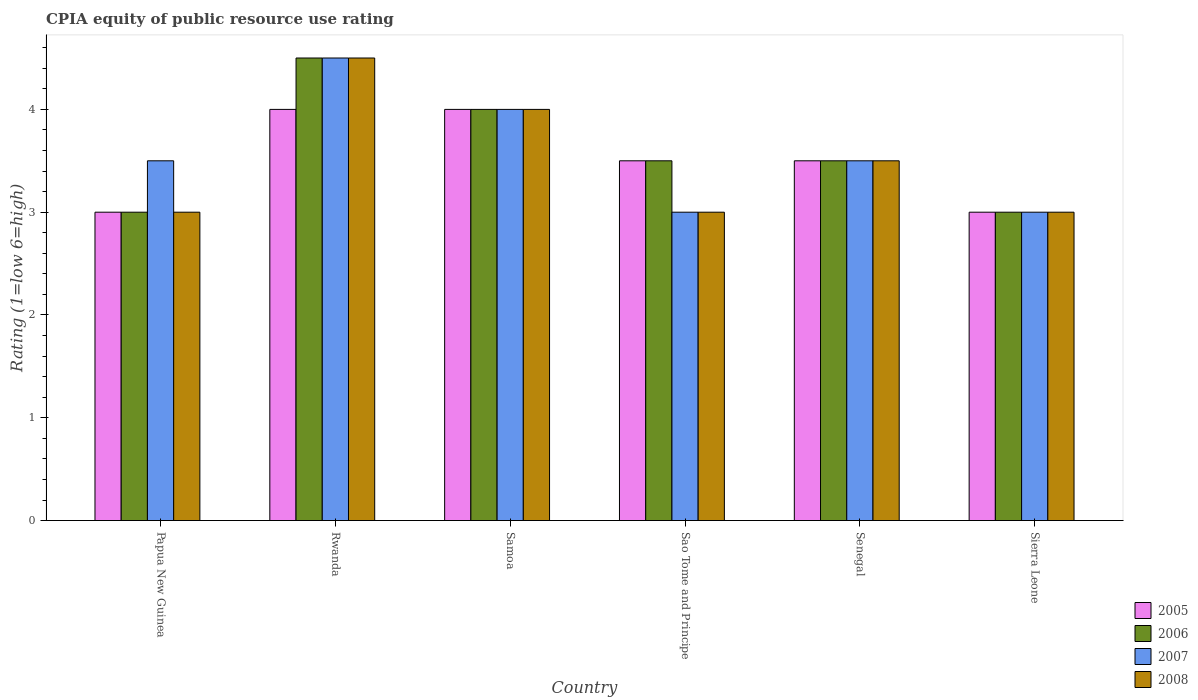How many groups of bars are there?
Ensure brevity in your answer.  6. Are the number of bars per tick equal to the number of legend labels?
Ensure brevity in your answer.  Yes. Are the number of bars on each tick of the X-axis equal?
Ensure brevity in your answer.  Yes. What is the label of the 3rd group of bars from the left?
Your answer should be compact. Samoa. Across all countries, what is the maximum CPIA rating in 2005?
Your answer should be compact. 4. Across all countries, what is the minimum CPIA rating in 2005?
Give a very brief answer. 3. In which country was the CPIA rating in 2007 maximum?
Your answer should be compact. Rwanda. In which country was the CPIA rating in 2008 minimum?
Make the answer very short. Papua New Guinea. What is the difference between the CPIA rating in 2005 in Samoa and that in Sao Tome and Principe?
Provide a short and direct response. 0.5. What is the average CPIA rating in 2008 per country?
Make the answer very short. 3.5. What is the difference between the CPIA rating of/in 2007 and CPIA rating of/in 2005 in Rwanda?
Make the answer very short. 0.5. What is the difference between the highest and the second highest CPIA rating in 2008?
Give a very brief answer. -1. What is the difference between the highest and the lowest CPIA rating in 2005?
Keep it short and to the point. 1. In how many countries, is the CPIA rating in 2007 greater than the average CPIA rating in 2007 taken over all countries?
Your answer should be very brief. 2. Is the sum of the CPIA rating in 2008 in Rwanda and Sao Tome and Principe greater than the maximum CPIA rating in 2006 across all countries?
Make the answer very short. Yes. What does the 2nd bar from the right in Senegal represents?
Your answer should be very brief. 2007. Is it the case that in every country, the sum of the CPIA rating in 2005 and CPIA rating in 2008 is greater than the CPIA rating in 2006?
Provide a short and direct response. Yes. How many countries are there in the graph?
Your answer should be compact. 6. Are the values on the major ticks of Y-axis written in scientific E-notation?
Make the answer very short. No. Does the graph contain any zero values?
Provide a short and direct response. No. Where does the legend appear in the graph?
Make the answer very short. Bottom right. How many legend labels are there?
Provide a short and direct response. 4. What is the title of the graph?
Offer a terse response. CPIA equity of public resource use rating. Does "1960" appear as one of the legend labels in the graph?
Make the answer very short. No. What is the label or title of the Y-axis?
Keep it short and to the point. Rating (1=low 6=high). What is the Rating (1=low 6=high) in 2005 in Papua New Guinea?
Your response must be concise. 3. What is the Rating (1=low 6=high) in 2006 in Papua New Guinea?
Ensure brevity in your answer.  3. What is the Rating (1=low 6=high) of 2008 in Papua New Guinea?
Offer a terse response. 3. What is the Rating (1=low 6=high) of 2005 in Rwanda?
Provide a succinct answer. 4. What is the Rating (1=low 6=high) in 2006 in Rwanda?
Provide a succinct answer. 4.5. What is the Rating (1=low 6=high) in 2005 in Samoa?
Your answer should be compact. 4. What is the Rating (1=low 6=high) in 2008 in Samoa?
Your answer should be very brief. 4. What is the Rating (1=low 6=high) of 2005 in Sao Tome and Principe?
Make the answer very short. 3.5. What is the Rating (1=low 6=high) in 2006 in Sao Tome and Principe?
Your response must be concise. 3.5. What is the Rating (1=low 6=high) of 2007 in Sao Tome and Principe?
Provide a short and direct response. 3. What is the Rating (1=low 6=high) of 2008 in Sao Tome and Principe?
Your answer should be compact. 3. What is the Rating (1=low 6=high) of 2006 in Senegal?
Offer a terse response. 3.5. What is the Rating (1=low 6=high) of 2007 in Sierra Leone?
Provide a short and direct response. 3. What is the Rating (1=low 6=high) in 2008 in Sierra Leone?
Provide a short and direct response. 3. Across all countries, what is the maximum Rating (1=low 6=high) of 2007?
Provide a succinct answer. 4.5. Across all countries, what is the minimum Rating (1=low 6=high) in 2006?
Ensure brevity in your answer.  3. Across all countries, what is the minimum Rating (1=low 6=high) of 2007?
Provide a succinct answer. 3. What is the total Rating (1=low 6=high) of 2005 in the graph?
Make the answer very short. 21. What is the total Rating (1=low 6=high) of 2008 in the graph?
Provide a short and direct response. 21. What is the difference between the Rating (1=low 6=high) of 2008 in Papua New Guinea and that in Rwanda?
Provide a succinct answer. -1.5. What is the difference between the Rating (1=low 6=high) of 2006 in Papua New Guinea and that in Samoa?
Offer a very short reply. -1. What is the difference between the Rating (1=low 6=high) in 2006 in Papua New Guinea and that in Sao Tome and Principe?
Your answer should be compact. -0.5. What is the difference between the Rating (1=low 6=high) of 2007 in Papua New Guinea and that in Sao Tome and Principe?
Your answer should be compact. 0.5. What is the difference between the Rating (1=low 6=high) in 2005 in Papua New Guinea and that in Sierra Leone?
Your answer should be very brief. 0. What is the difference between the Rating (1=low 6=high) in 2007 in Papua New Guinea and that in Sierra Leone?
Give a very brief answer. 0.5. What is the difference between the Rating (1=low 6=high) in 2008 in Papua New Guinea and that in Sierra Leone?
Keep it short and to the point. 0. What is the difference between the Rating (1=low 6=high) of 2005 in Rwanda and that in Samoa?
Keep it short and to the point. 0. What is the difference between the Rating (1=low 6=high) in 2006 in Rwanda and that in Samoa?
Offer a terse response. 0.5. What is the difference between the Rating (1=low 6=high) of 2007 in Rwanda and that in Samoa?
Make the answer very short. 0.5. What is the difference between the Rating (1=low 6=high) in 2008 in Rwanda and that in Samoa?
Offer a very short reply. 0.5. What is the difference between the Rating (1=low 6=high) in 2005 in Rwanda and that in Sao Tome and Principe?
Make the answer very short. 0.5. What is the difference between the Rating (1=low 6=high) in 2007 in Rwanda and that in Sao Tome and Principe?
Give a very brief answer. 1.5. What is the difference between the Rating (1=low 6=high) in 2008 in Rwanda and that in Senegal?
Give a very brief answer. 1. What is the difference between the Rating (1=low 6=high) in 2008 in Rwanda and that in Sierra Leone?
Provide a short and direct response. 1.5. What is the difference between the Rating (1=low 6=high) of 2005 in Samoa and that in Sao Tome and Principe?
Make the answer very short. 0.5. What is the difference between the Rating (1=low 6=high) in 2007 in Samoa and that in Sao Tome and Principe?
Your response must be concise. 1. What is the difference between the Rating (1=low 6=high) of 2005 in Samoa and that in Senegal?
Make the answer very short. 0.5. What is the difference between the Rating (1=low 6=high) of 2005 in Samoa and that in Sierra Leone?
Give a very brief answer. 1. What is the difference between the Rating (1=low 6=high) in 2007 in Samoa and that in Sierra Leone?
Provide a short and direct response. 1. What is the difference between the Rating (1=low 6=high) of 2008 in Samoa and that in Sierra Leone?
Your answer should be very brief. 1. What is the difference between the Rating (1=low 6=high) in 2006 in Sao Tome and Principe and that in Senegal?
Provide a short and direct response. 0. What is the difference between the Rating (1=low 6=high) in 2005 in Sao Tome and Principe and that in Sierra Leone?
Make the answer very short. 0.5. What is the difference between the Rating (1=low 6=high) in 2008 in Sao Tome and Principe and that in Sierra Leone?
Make the answer very short. 0. What is the difference between the Rating (1=low 6=high) of 2005 in Senegal and that in Sierra Leone?
Offer a very short reply. 0.5. What is the difference between the Rating (1=low 6=high) of 2007 in Senegal and that in Sierra Leone?
Your answer should be compact. 0.5. What is the difference between the Rating (1=low 6=high) in 2008 in Senegal and that in Sierra Leone?
Keep it short and to the point. 0.5. What is the difference between the Rating (1=low 6=high) of 2005 in Papua New Guinea and the Rating (1=low 6=high) of 2007 in Rwanda?
Offer a terse response. -1.5. What is the difference between the Rating (1=low 6=high) in 2006 in Papua New Guinea and the Rating (1=low 6=high) in 2007 in Rwanda?
Your response must be concise. -1.5. What is the difference between the Rating (1=low 6=high) of 2005 in Papua New Guinea and the Rating (1=low 6=high) of 2008 in Samoa?
Give a very brief answer. -1. What is the difference between the Rating (1=low 6=high) of 2006 in Papua New Guinea and the Rating (1=low 6=high) of 2007 in Samoa?
Make the answer very short. -1. What is the difference between the Rating (1=low 6=high) of 2007 in Papua New Guinea and the Rating (1=low 6=high) of 2008 in Samoa?
Provide a succinct answer. -0.5. What is the difference between the Rating (1=low 6=high) of 2005 in Papua New Guinea and the Rating (1=low 6=high) of 2008 in Sao Tome and Principe?
Ensure brevity in your answer.  0. What is the difference between the Rating (1=low 6=high) in 2006 in Papua New Guinea and the Rating (1=low 6=high) in 2008 in Sao Tome and Principe?
Offer a very short reply. 0. What is the difference between the Rating (1=low 6=high) of 2007 in Papua New Guinea and the Rating (1=low 6=high) of 2008 in Sao Tome and Principe?
Make the answer very short. 0.5. What is the difference between the Rating (1=low 6=high) of 2005 in Papua New Guinea and the Rating (1=low 6=high) of 2006 in Senegal?
Ensure brevity in your answer.  -0.5. What is the difference between the Rating (1=low 6=high) in 2005 in Papua New Guinea and the Rating (1=low 6=high) in 2007 in Senegal?
Keep it short and to the point. -0.5. What is the difference between the Rating (1=low 6=high) of 2005 in Papua New Guinea and the Rating (1=low 6=high) of 2008 in Senegal?
Provide a succinct answer. -0.5. What is the difference between the Rating (1=low 6=high) in 2006 in Papua New Guinea and the Rating (1=low 6=high) in 2008 in Senegal?
Your answer should be compact. -0.5. What is the difference between the Rating (1=low 6=high) of 2005 in Papua New Guinea and the Rating (1=low 6=high) of 2007 in Sierra Leone?
Offer a terse response. 0. What is the difference between the Rating (1=low 6=high) in 2007 in Papua New Guinea and the Rating (1=low 6=high) in 2008 in Sierra Leone?
Make the answer very short. 0.5. What is the difference between the Rating (1=low 6=high) in 2005 in Rwanda and the Rating (1=low 6=high) in 2007 in Samoa?
Your answer should be very brief. 0. What is the difference between the Rating (1=low 6=high) of 2006 in Rwanda and the Rating (1=low 6=high) of 2007 in Samoa?
Make the answer very short. 0.5. What is the difference between the Rating (1=low 6=high) of 2006 in Rwanda and the Rating (1=low 6=high) of 2008 in Samoa?
Offer a terse response. 0.5. What is the difference between the Rating (1=low 6=high) of 2006 in Rwanda and the Rating (1=low 6=high) of 2008 in Sao Tome and Principe?
Ensure brevity in your answer.  1.5. What is the difference between the Rating (1=low 6=high) of 2007 in Rwanda and the Rating (1=low 6=high) of 2008 in Sao Tome and Principe?
Provide a short and direct response. 1.5. What is the difference between the Rating (1=low 6=high) of 2005 in Rwanda and the Rating (1=low 6=high) of 2006 in Senegal?
Keep it short and to the point. 0.5. What is the difference between the Rating (1=low 6=high) of 2005 in Rwanda and the Rating (1=low 6=high) of 2008 in Senegal?
Offer a very short reply. 0.5. What is the difference between the Rating (1=low 6=high) in 2006 in Rwanda and the Rating (1=low 6=high) in 2007 in Senegal?
Ensure brevity in your answer.  1. What is the difference between the Rating (1=low 6=high) of 2006 in Rwanda and the Rating (1=low 6=high) of 2008 in Senegal?
Offer a terse response. 1. What is the difference between the Rating (1=low 6=high) of 2005 in Rwanda and the Rating (1=low 6=high) of 2007 in Sierra Leone?
Ensure brevity in your answer.  1. What is the difference between the Rating (1=low 6=high) of 2006 in Rwanda and the Rating (1=low 6=high) of 2007 in Sierra Leone?
Keep it short and to the point. 1.5. What is the difference between the Rating (1=low 6=high) of 2007 in Rwanda and the Rating (1=low 6=high) of 2008 in Sierra Leone?
Your response must be concise. 1.5. What is the difference between the Rating (1=low 6=high) of 2005 in Samoa and the Rating (1=low 6=high) of 2007 in Sao Tome and Principe?
Ensure brevity in your answer.  1. What is the difference between the Rating (1=low 6=high) in 2007 in Samoa and the Rating (1=low 6=high) in 2008 in Sao Tome and Principe?
Your answer should be compact. 1. What is the difference between the Rating (1=low 6=high) in 2005 in Samoa and the Rating (1=low 6=high) in 2008 in Senegal?
Your answer should be very brief. 0.5. What is the difference between the Rating (1=low 6=high) in 2006 in Samoa and the Rating (1=low 6=high) in 2007 in Senegal?
Your answer should be compact. 0.5. What is the difference between the Rating (1=low 6=high) in 2006 in Samoa and the Rating (1=low 6=high) in 2008 in Senegal?
Ensure brevity in your answer.  0.5. What is the difference between the Rating (1=low 6=high) of 2007 in Samoa and the Rating (1=low 6=high) of 2008 in Senegal?
Make the answer very short. 0.5. What is the difference between the Rating (1=low 6=high) in 2005 in Samoa and the Rating (1=low 6=high) in 2007 in Sierra Leone?
Offer a terse response. 1. What is the difference between the Rating (1=low 6=high) in 2005 in Samoa and the Rating (1=low 6=high) in 2008 in Sierra Leone?
Provide a succinct answer. 1. What is the difference between the Rating (1=low 6=high) of 2005 in Sao Tome and Principe and the Rating (1=low 6=high) of 2006 in Senegal?
Offer a very short reply. 0. What is the difference between the Rating (1=low 6=high) in 2005 in Sao Tome and Principe and the Rating (1=low 6=high) in 2007 in Senegal?
Ensure brevity in your answer.  0. What is the difference between the Rating (1=low 6=high) of 2006 in Sao Tome and Principe and the Rating (1=low 6=high) of 2007 in Senegal?
Your answer should be very brief. 0. What is the difference between the Rating (1=low 6=high) of 2006 in Sao Tome and Principe and the Rating (1=low 6=high) of 2008 in Senegal?
Provide a short and direct response. 0. What is the difference between the Rating (1=low 6=high) in 2005 in Sao Tome and Principe and the Rating (1=low 6=high) in 2007 in Sierra Leone?
Your answer should be very brief. 0.5. What is the difference between the Rating (1=low 6=high) in 2005 in Sao Tome and Principe and the Rating (1=low 6=high) in 2008 in Sierra Leone?
Offer a very short reply. 0.5. What is the difference between the Rating (1=low 6=high) of 2007 in Sao Tome and Principe and the Rating (1=low 6=high) of 2008 in Sierra Leone?
Your answer should be compact. 0. What is the difference between the Rating (1=low 6=high) in 2005 in Senegal and the Rating (1=low 6=high) in 2007 in Sierra Leone?
Give a very brief answer. 0.5. What is the difference between the Rating (1=low 6=high) in 2006 in Senegal and the Rating (1=low 6=high) in 2008 in Sierra Leone?
Your response must be concise. 0.5. What is the difference between the Rating (1=low 6=high) in 2007 in Senegal and the Rating (1=low 6=high) in 2008 in Sierra Leone?
Your answer should be compact. 0.5. What is the average Rating (1=low 6=high) of 2005 per country?
Your answer should be compact. 3.5. What is the average Rating (1=low 6=high) of 2006 per country?
Keep it short and to the point. 3.58. What is the average Rating (1=low 6=high) of 2007 per country?
Ensure brevity in your answer.  3.58. What is the average Rating (1=low 6=high) of 2008 per country?
Provide a short and direct response. 3.5. What is the difference between the Rating (1=low 6=high) in 2005 and Rating (1=low 6=high) in 2006 in Papua New Guinea?
Give a very brief answer. 0. What is the difference between the Rating (1=low 6=high) of 2007 and Rating (1=low 6=high) of 2008 in Papua New Guinea?
Your answer should be compact. 0.5. What is the difference between the Rating (1=low 6=high) of 2005 and Rating (1=low 6=high) of 2008 in Rwanda?
Give a very brief answer. -0.5. What is the difference between the Rating (1=low 6=high) of 2006 and Rating (1=low 6=high) of 2007 in Rwanda?
Your answer should be compact. 0. What is the difference between the Rating (1=low 6=high) of 2005 and Rating (1=low 6=high) of 2007 in Samoa?
Provide a short and direct response. 0. What is the difference between the Rating (1=low 6=high) of 2006 and Rating (1=low 6=high) of 2007 in Samoa?
Your answer should be compact. 0. What is the difference between the Rating (1=low 6=high) of 2007 and Rating (1=low 6=high) of 2008 in Samoa?
Give a very brief answer. 0. What is the difference between the Rating (1=low 6=high) of 2005 and Rating (1=low 6=high) of 2006 in Sao Tome and Principe?
Make the answer very short. 0. What is the difference between the Rating (1=low 6=high) in 2005 and Rating (1=low 6=high) in 2008 in Sao Tome and Principe?
Offer a terse response. 0.5. What is the difference between the Rating (1=low 6=high) of 2006 and Rating (1=low 6=high) of 2008 in Sao Tome and Principe?
Provide a short and direct response. 0.5. What is the difference between the Rating (1=low 6=high) of 2005 and Rating (1=low 6=high) of 2007 in Senegal?
Give a very brief answer. 0. What is the difference between the Rating (1=low 6=high) in 2005 and Rating (1=low 6=high) in 2008 in Senegal?
Provide a short and direct response. 0. What is the difference between the Rating (1=low 6=high) in 2006 and Rating (1=low 6=high) in 2007 in Senegal?
Offer a terse response. 0. What is the difference between the Rating (1=low 6=high) of 2005 and Rating (1=low 6=high) of 2006 in Sierra Leone?
Offer a very short reply. 0. What is the difference between the Rating (1=low 6=high) of 2005 and Rating (1=low 6=high) of 2007 in Sierra Leone?
Your response must be concise. 0. What is the difference between the Rating (1=low 6=high) of 2006 and Rating (1=low 6=high) of 2007 in Sierra Leone?
Give a very brief answer. 0. What is the ratio of the Rating (1=low 6=high) of 2005 in Papua New Guinea to that in Rwanda?
Provide a succinct answer. 0.75. What is the ratio of the Rating (1=low 6=high) in 2007 in Papua New Guinea to that in Rwanda?
Offer a terse response. 0.78. What is the ratio of the Rating (1=low 6=high) in 2007 in Papua New Guinea to that in Samoa?
Your response must be concise. 0.88. What is the ratio of the Rating (1=low 6=high) in 2008 in Papua New Guinea to that in Samoa?
Ensure brevity in your answer.  0.75. What is the ratio of the Rating (1=low 6=high) in 2005 in Papua New Guinea to that in Sao Tome and Principe?
Give a very brief answer. 0.86. What is the ratio of the Rating (1=low 6=high) in 2007 in Papua New Guinea to that in Sao Tome and Principe?
Give a very brief answer. 1.17. What is the ratio of the Rating (1=low 6=high) in 2008 in Papua New Guinea to that in Sao Tome and Principe?
Keep it short and to the point. 1. What is the ratio of the Rating (1=low 6=high) in 2005 in Papua New Guinea to that in Senegal?
Give a very brief answer. 0.86. What is the ratio of the Rating (1=low 6=high) of 2006 in Papua New Guinea to that in Senegal?
Ensure brevity in your answer.  0.86. What is the ratio of the Rating (1=low 6=high) of 2008 in Papua New Guinea to that in Senegal?
Make the answer very short. 0.86. What is the ratio of the Rating (1=low 6=high) of 2005 in Papua New Guinea to that in Sierra Leone?
Make the answer very short. 1. What is the ratio of the Rating (1=low 6=high) of 2007 in Papua New Guinea to that in Sierra Leone?
Provide a short and direct response. 1.17. What is the ratio of the Rating (1=low 6=high) of 2008 in Papua New Guinea to that in Sierra Leone?
Ensure brevity in your answer.  1. What is the ratio of the Rating (1=low 6=high) in 2007 in Rwanda to that in Samoa?
Your response must be concise. 1.12. What is the ratio of the Rating (1=low 6=high) in 2008 in Rwanda to that in Samoa?
Your response must be concise. 1.12. What is the ratio of the Rating (1=low 6=high) in 2006 in Rwanda to that in Sao Tome and Principe?
Your response must be concise. 1.29. What is the ratio of the Rating (1=low 6=high) in 2007 in Rwanda to that in Sao Tome and Principe?
Your response must be concise. 1.5. What is the ratio of the Rating (1=low 6=high) in 2008 in Rwanda to that in Sao Tome and Principe?
Provide a succinct answer. 1.5. What is the ratio of the Rating (1=low 6=high) in 2008 in Rwanda to that in Senegal?
Your answer should be compact. 1.29. What is the ratio of the Rating (1=low 6=high) in 2006 in Rwanda to that in Sierra Leone?
Give a very brief answer. 1.5. What is the ratio of the Rating (1=low 6=high) of 2007 in Rwanda to that in Sierra Leone?
Provide a succinct answer. 1.5. What is the ratio of the Rating (1=low 6=high) in 2005 in Samoa to that in Sao Tome and Principe?
Provide a short and direct response. 1.14. What is the ratio of the Rating (1=low 6=high) in 2006 in Samoa to that in Senegal?
Make the answer very short. 1.14. What is the ratio of the Rating (1=low 6=high) in 2008 in Samoa to that in Senegal?
Keep it short and to the point. 1.14. What is the ratio of the Rating (1=low 6=high) in 2007 in Samoa to that in Sierra Leone?
Your response must be concise. 1.33. What is the ratio of the Rating (1=low 6=high) of 2005 in Sao Tome and Principe to that in Senegal?
Ensure brevity in your answer.  1. What is the ratio of the Rating (1=low 6=high) of 2006 in Sao Tome and Principe to that in Senegal?
Your answer should be very brief. 1. What is the ratio of the Rating (1=low 6=high) in 2008 in Sao Tome and Principe to that in Senegal?
Make the answer very short. 0.86. What is the ratio of the Rating (1=low 6=high) of 2006 in Sao Tome and Principe to that in Sierra Leone?
Provide a succinct answer. 1.17. What is the ratio of the Rating (1=low 6=high) in 2007 in Sao Tome and Principe to that in Sierra Leone?
Your answer should be compact. 1. What is the ratio of the Rating (1=low 6=high) of 2007 in Senegal to that in Sierra Leone?
Provide a short and direct response. 1.17. What is the ratio of the Rating (1=low 6=high) in 2008 in Senegal to that in Sierra Leone?
Your response must be concise. 1.17. What is the difference between the highest and the second highest Rating (1=low 6=high) of 2006?
Your answer should be compact. 0.5. What is the difference between the highest and the lowest Rating (1=low 6=high) in 2005?
Offer a very short reply. 1. What is the difference between the highest and the lowest Rating (1=low 6=high) in 2006?
Ensure brevity in your answer.  1.5. What is the difference between the highest and the lowest Rating (1=low 6=high) of 2008?
Offer a very short reply. 1.5. 